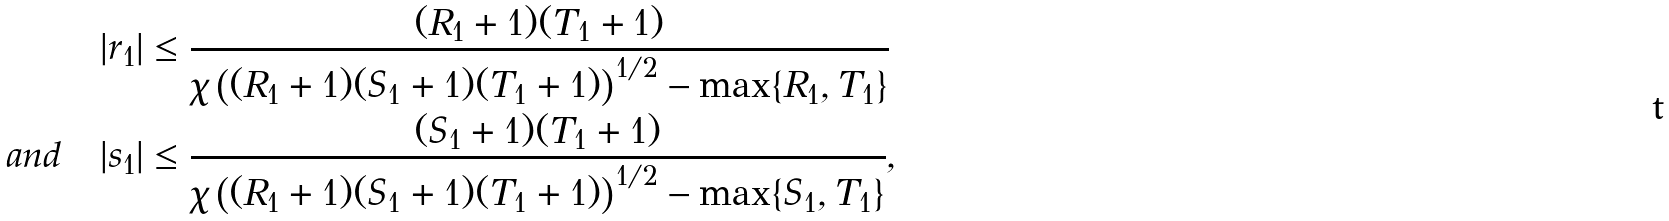Convert formula to latex. <formula><loc_0><loc_0><loc_500><loc_500>| r _ { 1 } | & \leq \frac { ( R _ { 1 } + 1 ) ( T _ { 1 } + 1 ) } { \chi \left ( ( R _ { 1 } + 1 ) ( S _ { 1 } + 1 ) ( T _ { 1 } + 1 ) \right ) ^ { 1 / 2 } - \max \{ R _ { 1 } , T _ { 1 } \} } \\ a n d \quad | s _ { 1 } | & \leq \frac { ( S _ { 1 } + 1 ) ( T _ { 1 } + 1 ) } { \chi \left ( ( R _ { 1 } + 1 ) ( S _ { 1 } + 1 ) ( T _ { 1 } + 1 ) \right ) ^ { 1 / 2 } - \max \{ S _ { 1 } , T _ { 1 } \} } ,</formula> 